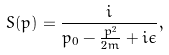<formula> <loc_0><loc_0><loc_500><loc_500>S ( p ) = \frac { i } { p _ { 0 } - \frac { { p } ^ { 2 } } { 2 m } + i \epsilon } ,</formula> 